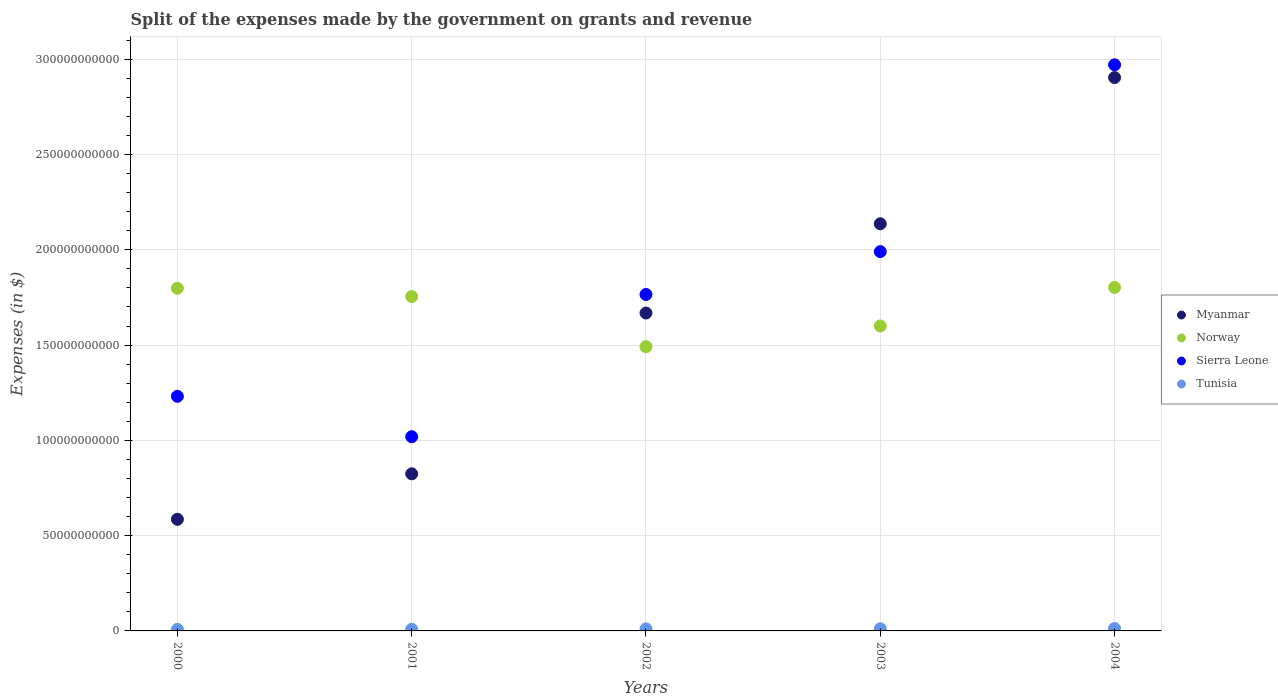How many different coloured dotlines are there?
Provide a short and direct response. 4. What is the expenses made by the government on grants and revenue in Sierra Leone in 2000?
Provide a succinct answer. 1.23e+11. Across all years, what is the maximum expenses made by the government on grants and revenue in Sierra Leone?
Your answer should be compact. 2.97e+11. Across all years, what is the minimum expenses made by the government on grants and revenue in Myanmar?
Keep it short and to the point. 5.86e+1. In which year was the expenses made by the government on grants and revenue in Sierra Leone minimum?
Provide a succinct answer. 2001. What is the total expenses made by the government on grants and revenue in Myanmar in the graph?
Offer a terse response. 8.12e+11. What is the difference between the expenses made by the government on grants and revenue in Sierra Leone in 2000 and that in 2001?
Your answer should be very brief. 2.12e+1. What is the difference between the expenses made by the government on grants and revenue in Norway in 2004 and the expenses made by the government on grants and revenue in Sierra Leone in 2003?
Keep it short and to the point. -1.88e+1. What is the average expenses made by the government on grants and revenue in Sierra Leone per year?
Make the answer very short. 1.80e+11. In the year 2002, what is the difference between the expenses made by the government on grants and revenue in Tunisia and expenses made by the government on grants and revenue in Sierra Leone?
Provide a short and direct response. -1.75e+11. In how many years, is the expenses made by the government on grants and revenue in Norway greater than 190000000000 $?
Keep it short and to the point. 0. What is the ratio of the expenses made by the government on grants and revenue in Sierra Leone in 2001 to that in 2003?
Make the answer very short. 0.51. Is the expenses made by the government on grants and revenue in Tunisia in 2000 less than that in 2004?
Provide a succinct answer. Yes. Is the difference between the expenses made by the government on grants and revenue in Tunisia in 2000 and 2003 greater than the difference between the expenses made by the government on grants and revenue in Sierra Leone in 2000 and 2003?
Provide a short and direct response. Yes. What is the difference between the highest and the second highest expenses made by the government on grants and revenue in Norway?
Provide a succinct answer. 4.25e+08. What is the difference between the highest and the lowest expenses made by the government on grants and revenue in Tunisia?
Give a very brief answer. 4.58e+08. In how many years, is the expenses made by the government on grants and revenue in Norway greater than the average expenses made by the government on grants and revenue in Norway taken over all years?
Give a very brief answer. 3. Is the sum of the expenses made by the government on grants and revenue in Norway in 2001 and 2003 greater than the maximum expenses made by the government on grants and revenue in Tunisia across all years?
Keep it short and to the point. Yes. Is it the case that in every year, the sum of the expenses made by the government on grants and revenue in Tunisia and expenses made by the government on grants and revenue in Sierra Leone  is greater than the sum of expenses made by the government on grants and revenue in Norway and expenses made by the government on grants and revenue in Myanmar?
Offer a terse response. No. Does the expenses made by the government on grants and revenue in Norway monotonically increase over the years?
Provide a succinct answer. No. Is the expenses made by the government on grants and revenue in Myanmar strictly greater than the expenses made by the government on grants and revenue in Norway over the years?
Keep it short and to the point. No. What is the difference between two consecutive major ticks on the Y-axis?
Make the answer very short. 5.00e+1. Does the graph contain any zero values?
Offer a terse response. No. Does the graph contain grids?
Offer a terse response. Yes. Where does the legend appear in the graph?
Ensure brevity in your answer.  Center right. How many legend labels are there?
Your answer should be very brief. 4. How are the legend labels stacked?
Your response must be concise. Vertical. What is the title of the graph?
Ensure brevity in your answer.  Split of the expenses made by the government on grants and revenue. What is the label or title of the Y-axis?
Give a very brief answer. Expenses (in $). What is the Expenses (in $) of Myanmar in 2000?
Your answer should be very brief. 5.86e+1. What is the Expenses (in $) in Norway in 2000?
Offer a very short reply. 1.80e+11. What is the Expenses (in $) in Sierra Leone in 2000?
Your answer should be very brief. 1.23e+11. What is the Expenses (in $) in Tunisia in 2000?
Make the answer very short. 8.20e+08. What is the Expenses (in $) of Myanmar in 2001?
Provide a short and direct response. 8.24e+1. What is the Expenses (in $) in Norway in 2001?
Keep it short and to the point. 1.75e+11. What is the Expenses (in $) in Sierra Leone in 2001?
Your response must be concise. 1.02e+11. What is the Expenses (in $) in Tunisia in 2001?
Provide a short and direct response. 8.76e+08. What is the Expenses (in $) of Myanmar in 2002?
Your answer should be compact. 1.67e+11. What is the Expenses (in $) in Norway in 2002?
Your response must be concise. 1.49e+11. What is the Expenses (in $) in Sierra Leone in 2002?
Offer a terse response. 1.77e+11. What is the Expenses (in $) in Tunisia in 2002?
Make the answer very short. 1.08e+09. What is the Expenses (in $) in Myanmar in 2003?
Offer a very short reply. 2.14e+11. What is the Expenses (in $) of Norway in 2003?
Offer a terse response. 1.60e+11. What is the Expenses (in $) of Sierra Leone in 2003?
Offer a terse response. 1.99e+11. What is the Expenses (in $) in Tunisia in 2003?
Ensure brevity in your answer.  1.14e+09. What is the Expenses (in $) of Myanmar in 2004?
Your answer should be compact. 2.90e+11. What is the Expenses (in $) in Norway in 2004?
Provide a succinct answer. 1.80e+11. What is the Expenses (in $) of Sierra Leone in 2004?
Offer a terse response. 2.97e+11. What is the Expenses (in $) of Tunisia in 2004?
Give a very brief answer. 1.28e+09. Across all years, what is the maximum Expenses (in $) of Myanmar?
Your answer should be compact. 2.90e+11. Across all years, what is the maximum Expenses (in $) of Norway?
Make the answer very short. 1.80e+11. Across all years, what is the maximum Expenses (in $) in Sierra Leone?
Provide a succinct answer. 2.97e+11. Across all years, what is the maximum Expenses (in $) of Tunisia?
Provide a succinct answer. 1.28e+09. Across all years, what is the minimum Expenses (in $) of Myanmar?
Offer a very short reply. 5.86e+1. Across all years, what is the minimum Expenses (in $) of Norway?
Your response must be concise. 1.49e+11. Across all years, what is the minimum Expenses (in $) of Sierra Leone?
Keep it short and to the point. 1.02e+11. Across all years, what is the minimum Expenses (in $) in Tunisia?
Make the answer very short. 8.20e+08. What is the total Expenses (in $) in Myanmar in the graph?
Provide a succinct answer. 8.12e+11. What is the total Expenses (in $) in Norway in the graph?
Give a very brief answer. 8.45e+11. What is the total Expenses (in $) of Sierra Leone in the graph?
Your response must be concise. 8.98e+11. What is the total Expenses (in $) in Tunisia in the graph?
Offer a very short reply. 5.20e+09. What is the difference between the Expenses (in $) of Myanmar in 2000 and that in 2001?
Offer a very short reply. -2.39e+1. What is the difference between the Expenses (in $) in Norway in 2000 and that in 2001?
Your answer should be very brief. 4.36e+09. What is the difference between the Expenses (in $) in Sierra Leone in 2000 and that in 2001?
Your response must be concise. 2.12e+1. What is the difference between the Expenses (in $) in Tunisia in 2000 and that in 2001?
Ensure brevity in your answer.  -5.55e+07. What is the difference between the Expenses (in $) in Myanmar in 2000 and that in 2002?
Your response must be concise. -1.08e+11. What is the difference between the Expenses (in $) of Norway in 2000 and that in 2002?
Offer a very short reply. 3.07e+1. What is the difference between the Expenses (in $) of Sierra Leone in 2000 and that in 2002?
Your answer should be compact. -5.34e+1. What is the difference between the Expenses (in $) in Tunisia in 2000 and that in 2002?
Your response must be concise. -2.64e+08. What is the difference between the Expenses (in $) in Myanmar in 2000 and that in 2003?
Your answer should be very brief. -1.55e+11. What is the difference between the Expenses (in $) in Norway in 2000 and that in 2003?
Keep it short and to the point. 1.98e+1. What is the difference between the Expenses (in $) in Sierra Leone in 2000 and that in 2003?
Give a very brief answer. -7.59e+1. What is the difference between the Expenses (in $) of Tunisia in 2000 and that in 2003?
Provide a short and direct response. -3.21e+08. What is the difference between the Expenses (in $) in Myanmar in 2000 and that in 2004?
Give a very brief answer. -2.32e+11. What is the difference between the Expenses (in $) in Norway in 2000 and that in 2004?
Provide a short and direct response. -4.25e+08. What is the difference between the Expenses (in $) of Sierra Leone in 2000 and that in 2004?
Provide a succinct answer. -1.74e+11. What is the difference between the Expenses (in $) of Tunisia in 2000 and that in 2004?
Provide a short and direct response. -4.58e+08. What is the difference between the Expenses (in $) in Myanmar in 2001 and that in 2002?
Give a very brief answer. -8.44e+1. What is the difference between the Expenses (in $) of Norway in 2001 and that in 2002?
Your answer should be very brief. 2.63e+1. What is the difference between the Expenses (in $) of Sierra Leone in 2001 and that in 2002?
Ensure brevity in your answer.  -7.46e+1. What is the difference between the Expenses (in $) in Tunisia in 2001 and that in 2002?
Provide a short and direct response. -2.09e+08. What is the difference between the Expenses (in $) in Myanmar in 2001 and that in 2003?
Make the answer very short. -1.31e+11. What is the difference between the Expenses (in $) of Norway in 2001 and that in 2003?
Offer a very short reply. 1.54e+1. What is the difference between the Expenses (in $) in Sierra Leone in 2001 and that in 2003?
Keep it short and to the point. -9.71e+1. What is the difference between the Expenses (in $) in Tunisia in 2001 and that in 2003?
Make the answer very short. -2.66e+08. What is the difference between the Expenses (in $) in Myanmar in 2001 and that in 2004?
Your response must be concise. -2.08e+11. What is the difference between the Expenses (in $) in Norway in 2001 and that in 2004?
Keep it short and to the point. -4.79e+09. What is the difference between the Expenses (in $) of Sierra Leone in 2001 and that in 2004?
Your response must be concise. -1.95e+11. What is the difference between the Expenses (in $) in Tunisia in 2001 and that in 2004?
Make the answer very short. -4.02e+08. What is the difference between the Expenses (in $) in Myanmar in 2002 and that in 2003?
Your response must be concise. -4.68e+1. What is the difference between the Expenses (in $) of Norway in 2002 and that in 2003?
Give a very brief answer. -1.09e+1. What is the difference between the Expenses (in $) in Sierra Leone in 2002 and that in 2003?
Keep it short and to the point. -2.25e+1. What is the difference between the Expenses (in $) in Tunisia in 2002 and that in 2003?
Ensure brevity in your answer.  -5.66e+07. What is the difference between the Expenses (in $) in Myanmar in 2002 and that in 2004?
Provide a succinct answer. -1.24e+11. What is the difference between the Expenses (in $) of Norway in 2002 and that in 2004?
Offer a very short reply. -3.11e+1. What is the difference between the Expenses (in $) in Sierra Leone in 2002 and that in 2004?
Provide a succinct answer. -1.21e+11. What is the difference between the Expenses (in $) of Tunisia in 2002 and that in 2004?
Offer a terse response. -1.94e+08. What is the difference between the Expenses (in $) in Myanmar in 2003 and that in 2004?
Provide a short and direct response. -7.67e+1. What is the difference between the Expenses (in $) in Norway in 2003 and that in 2004?
Provide a short and direct response. -2.02e+1. What is the difference between the Expenses (in $) in Sierra Leone in 2003 and that in 2004?
Provide a short and direct response. -9.80e+1. What is the difference between the Expenses (in $) in Tunisia in 2003 and that in 2004?
Give a very brief answer. -1.37e+08. What is the difference between the Expenses (in $) in Myanmar in 2000 and the Expenses (in $) in Norway in 2001?
Your answer should be compact. -1.17e+11. What is the difference between the Expenses (in $) of Myanmar in 2000 and the Expenses (in $) of Sierra Leone in 2001?
Ensure brevity in your answer.  -4.34e+1. What is the difference between the Expenses (in $) in Myanmar in 2000 and the Expenses (in $) in Tunisia in 2001?
Your response must be concise. 5.77e+1. What is the difference between the Expenses (in $) in Norway in 2000 and the Expenses (in $) in Sierra Leone in 2001?
Provide a succinct answer. 7.79e+1. What is the difference between the Expenses (in $) of Norway in 2000 and the Expenses (in $) of Tunisia in 2001?
Keep it short and to the point. 1.79e+11. What is the difference between the Expenses (in $) in Sierra Leone in 2000 and the Expenses (in $) in Tunisia in 2001?
Ensure brevity in your answer.  1.22e+11. What is the difference between the Expenses (in $) of Myanmar in 2000 and the Expenses (in $) of Norway in 2002?
Provide a short and direct response. -9.06e+1. What is the difference between the Expenses (in $) in Myanmar in 2000 and the Expenses (in $) in Sierra Leone in 2002?
Keep it short and to the point. -1.18e+11. What is the difference between the Expenses (in $) in Myanmar in 2000 and the Expenses (in $) in Tunisia in 2002?
Provide a succinct answer. 5.75e+1. What is the difference between the Expenses (in $) in Norway in 2000 and the Expenses (in $) in Sierra Leone in 2002?
Ensure brevity in your answer.  3.26e+09. What is the difference between the Expenses (in $) in Norway in 2000 and the Expenses (in $) in Tunisia in 2002?
Ensure brevity in your answer.  1.79e+11. What is the difference between the Expenses (in $) in Sierra Leone in 2000 and the Expenses (in $) in Tunisia in 2002?
Your answer should be very brief. 1.22e+11. What is the difference between the Expenses (in $) in Myanmar in 2000 and the Expenses (in $) in Norway in 2003?
Keep it short and to the point. -1.01e+11. What is the difference between the Expenses (in $) in Myanmar in 2000 and the Expenses (in $) in Sierra Leone in 2003?
Ensure brevity in your answer.  -1.40e+11. What is the difference between the Expenses (in $) in Myanmar in 2000 and the Expenses (in $) in Tunisia in 2003?
Ensure brevity in your answer.  5.74e+1. What is the difference between the Expenses (in $) in Norway in 2000 and the Expenses (in $) in Sierra Leone in 2003?
Your response must be concise. -1.92e+1. What is the difference between the Expenses (in $) of Norway in 2000 and the Expenses (in $) of Tunisia in 2003?
Make the answer very short. 1.79e+11. What is the difference between the Expenses (in $) of Sierra Leone in 2000 and the Expenses (in $) of Tunisia in 2003?
Your answer should be very brief. 1.22e+11. What is the difference between the Expenses (in $) of Myanmar in 2000 and the Expenses (in $) of Norway in 2004?
Keep it short and to the point. -1.22e+11. What is the difference between the Expenses (in $) of Myanmar in 2000 and the Expenses (in $) of Sierra Leone in 2004?
Make the answer very short. -2.39e+11. What is the difference between the Expenses (in $) of Myanmar in 2000 and the Expenses (in $) of Tunisia in 2004?
Your response must be concise. 5.73e+1. What is the difference between the Expenses (in $) in Norway in 2000 and the Expenses (in $) in Sierra Leone in 2004?
Your response must be concise. -1.17e+11. What is the difference between the Expenses (in $) in Norway in 2000 and the Expenses (in $) in Tunisia in 2004?
Provide a short and direct response. 1.79e+11. What is the difference between the Expenses (in $) of Sierra Leone in 2000 and the Expenses (in $) of Tunisia in 2004?
Provide a short and direct response. 1.22e+11. What is the difference between the Expenses (in $) of Myanmar in 2001 and the Expenses (in $) of Norway in 2002?
Offer a terse response. -6.67e+1. What is the difference between the Expenses (in $) in Myanmar in 2001 and the Expenses (in $) in Sierra Leone in 2002?
Offer a terse response. -9.41e+1. What is the difference between the Expenses (in $) of Myanmar in 2001 and the Expenses (in $) of Tunisia in 2002?
Your answer should be very brief. 8.14e+1. What is the difference between the Expenses (in $) of Norway in 2001 and the Expenses (in $) of Sierra Leone in 2002?
Your response must be concise. -1.10e+09. What is the difference between the Expenses (in $) of Norway in 2001 and the Expenses (in $) of Tunisia in 2002?
Offer a very short reply. 1.74e+11. What is the difference between the Expenses (in $) in Sierra Leone in 2001 and the Expenses (in $) in Tunisia in 2002?
Your response must be concise. 1.01e+11. What is the difference between the Expenses (in $) of Myanmar in 2001 and the Expenses (in $) of Norway in 2003?
Offer a very short reply. -7.76e+1. What is the difference between the Expenses (in $) in Myanmar in 2001 and the Expenses (in $) in Sierra Leone in 2003?
Keep it short and to the point. -1.17e+11. What is the difference between the Expenses (in $) of Myanmar in 2001 and the Expenses (in $) of Tunisia in 2003?
Ensure brevity in your answer.  8.13e+1. What is the difference between the Expenses (in $) of Norway in 2001 and the Expenses (in $) of Sierra Leone in 2003?
Offer a terse response. -2.36e+1. What is the difference between the Expenses (in $) in Norway in 2001 and the Expenses (in $) in Tunisia in 2003?
Offer a terse response. 1.74e+11. What is the difference between the Expenses (in $) of Sierra Leone in 2001 and the Expenses (in $) of Tunisia in 2003?
Give a very brief answer. 1.01e+11. What is the difference between the Expenses (in $) in Myanmar in 2001 and the Expenses (in $) in Norway in 2004?
Your response must be concise. -9.78e+1. What is the difference between the Expenses (in $) of Myanmar in 2001 and the Expenses (in $) of Sierra Leone in 2004?
Provide a succinct answer. -2.15e+11. What is the difference between the Expenses (in $) in Myanmar in 2001 and the Expenses (in $) in Tunisia in 2004?
Make the answer very short. 8.12e+1. What is the difference between the Expenses (in $) of Norway in 2001 and the Expenses (in $) of Sierra Leone in 2004?
Offer a very short reply. -1.22e+11. What is the difference between the Expenses (in $) in Norway in 2001 and the Expenses (in $) in Tunisia in 2004?
Give a very brief answer. 1.74e+11. What is the difference between the Expenses (in $) in Sierra Leone in 2001 and the Expenses (in $) in Tunisia in 2004?
Give a very brief answer. 1.01e+11. What is the difference between the Expenses (in $) in Myanmar in 2002 and the Expenses (in $) in Norway in 2003?
Offer a terse response. 6.78e+09. What is the difference between the Expenses (in $) of Myanmar in 2002 and the Expenses (in $) of Sierra Leone in 2003?
Offer a very short reply. -3.22e+1. What is the difference between the Expenses (in $) of Myanmar in 2002 and the Expenses (in $) of Tunisia in 2003?
Ensure brevity in your answer.  1.66e+11. What is the difference between the Expenses (in $) of Norway in 2002 and the Expenses (in $) of Sierra Leone in 2003?
Your response must be concise. -4.99e+1. What is the difference between the Expenses (in $) of Norway in 2002 and the Expenses (in $) of Tunisia in 2003?
Keep it short and to the point. 1.48e+11. What is the difference between the Expenses (in $) of Sierra Leone in 2002 and the Expenses (in $) of Tunisia in 2003?
Make the answer very short. 1.75e+11. What is the difference between the Expenses (in $) of Myanmar in 2002 and the Expenses (in $) of Norway in 2004?
Provide a short and direct response. -1.34e+1. What is the difference between the Expenses (in $) in Myanmar in 2002 and the Expenses (in $) in Sierra Leone in 2004?
Your answer should be very brief. -1.30e+11. What is the difference between the Expenses (in $) in Myanmar in 2002 and the Expenses (in $) in Tunisia in 2004?
Keep it short and to the point. 1.66e+11. What is the difference between the Expenses (in $) in Norway in 2002 and the Expenses (in $) in Sierra Leone in 2004?
Your response must be concise. -1.48e+11. What is the difference between the Expenses (in $) in Norway in 2002 and the Expenses (in $) in Tunisia in 2004?
Keep it short and to the point. 1.48e+11. What is the difference between the Expenses (in $) in Sierra Leone in 2002 and the Expenses (in $) in Tunisia in 2004?
Ensure brevity in your answer.  1.75e+11. What is the difference between the Expenses (in $) in Myanmar in 2003 and the Expenses (in $) in Norway in 2004?
Ensure brevity in your answer.  3.34e+1. What is the difference between the Expenses (in $) in Myanmar in 2003 and the Expenses (in $) in Sierra Leone in 2004?
Provide a succinct answer. -8.34e+1. What is the difference between the Expenses (in $) in Myanmar in 2003 and the Expenses (in $) in Tunisia in 2004?
Your answer should be very brief. 2.12e+11. What is the difference between the Expenses (in $) of Norway in 2003 and the Expenses (in $) of Sierra Leone in 2004?
Keep it short and to the point. -1.37e+11. What is the difference between the Expenses (in $) in Norway in 2003 and the Expenses (in $) in Tunisia in 2004?
Provide a succinct answer. 1.59e+11. What is the difference between the Expenses (in $) in Sierra Leone in 2003 and the Expenses (in $) in Tunisia in 2004?
Your answer should be compact. 1.98e+11. What is the average Expenses (in $) of Myanmar per year?
Make the answer very short. 1.62e+11. What is the average Expenses (in $) in Norway per year?
Provide a succinct answer. 1.69e+11. What is the average Expenses (in $) in Sierra Leone per year?
Your answer should be compact. 1.80e+11. What is the average Expenses (in $) in Tunisia per year?
Your answer should be compact. 1.04e+09. In the year 2000, what is the difference between the Expenses (in $) of Myanmar and Expenses (in $) of Norway?
Make the answer very short. -1.21e+11. In the year 2000, what is the difference between the Expenses (in $) in Myanmar and Expenses (in $) in Sierra Leone?
Keep it short and to the point. -6.45e+1. In the year 2000, what is the difference between the Expenses (in $) of Myanmar and Expenses (in $) of Tunisia?
Give a very brief answer. 5.77e+1. In the year 2000, what is the difference between the Expenses (in $) in Norway and Expenses (in $) in Sierra Leone?
Your answer should be compact. 5.67e+1. In the year 2000, what is the difference between the Expenses (in $) in Norway and Expenses (in $) in Tunisia?
Your response must be concise. 1.79e+11. In the year 2000, what is the difference between the Expenses (in $) of Sierra Leone and Expenses (in $) of Tunisia?
Make the answer very short. 1.22e+11. In the year 2001, what is the difference between the Expenses (in $) in Myanmar and Expenses (in $) in Norway?
Provide a succinct answer. -9.30e+1. In the year 2001, what is the difference between the Expenses (in $) in Myanmar and Expenses (in $) in Sierra Leone?
Your answer should be compact. -1.95e+1. In the year 2001, what is the difference between the Expenses (in $) in Myanmar and Expenses (in $) in Tunisia?
Your answer should be compact. 8.16e+1. In the year 2001, what is the difference between the Expenses (in $) of Norway and Expenses (in $) of Sierra Leone?
Ensure brevity in your answer.  7.35e+1. In the year 2001, what is the difference between the Expenses (in $) of Norway and Expenses (in $) of Tunisia?
Make the answer very short. 1.75e+11. In the year 2001, what is the difference between the Expenses (in $) in Sierra Leone and Expenses (in $) in Tunisia?
Your answer should be compact. 1.01e+11. In the year 2002, what is the difference between the Expenses (in $) of Myanmar and Expenses (in $) of Norway?
Ensure brevity in your answer.  1.77e+1. In the year 2002, what is the difference between the Expenses (in $) of Myanmar and Expenses (in $) of Sierra Leone?
Your response must be concise. -9.74e+09. In the year 2002, what is the difference between the Expenses (in $) of Myanmar and Expenses (in $) of Tunisia?
Provide a succinct answer. 1.66e+11. In the year 2002, what is the difference between the Expenses (in $) of Norway and Expenses (in $) of Sierra Leone?
Give a very brief answer. -2.74e+1. In the year 2002, what is the difference between the Expenses (in $) in Norway and Expenses (in $) in Tunisia?
Offer a terse response. 1.48e+11. In the year 2002, what is the difference between the Expenses (in $) of Sierra Leone and Expenses (in $) of Tunisia?
Your answer should be compact. 1.75e+11. In the year 2003, what is the difference between the Expenses (in $) of Myanmar and Expenses (in $) of Norway?
Your answer should be very brief. 5.36e+1. In the year 2003, what is the difference between the Expenses (in $) of Myanmar and Expenses (in $) of Sierra Leone?
Provide a short and direct response. 1.46e+1. In the year 2003, what is the difference between the Expenses (in $) in Myanmar and Expenses (in $) in Tunisia?
Keep it short and to the point. 2.13e+11. In the year 2003, what is the difference between the Expenses (in $) in Norway and Expenses (in $) in Sierra Leone?
Your answer should be very brief. -3.90e+1. In the year 2003, what is the difference between the Expenses (in $) of Norway and Expenses (in $) of Tunisia?
Your answer should be compact. 1.59e+11. In the year 2003, what is the difference between the Expenses (in $) of Sierra Leone and Expenses (in $) of Tunisia?
Offer a very short reply. 1.98e+11. In the year 2004, what is the difference between the Expenses (in $) of Myanmar and Expenses (in $) of Norway?
Give a very brief answer. 1.10e+11. In the year 2004, what is the difference between the Expenses (in $) of Myanmar and Expenses (in $) of Sierra Leone?
Keep it short and to the point. -6.71e+09. In the year 2004, what is the difference between the Expenses (in $) of Myanmar and Expenses (in $) of Tunisia?
Give a very brief answer. 2.89e+11. In the year 2004, what is the difference between the Expenses (in $) of Norway and Expenses (in $) of Sierra Leone?
Your answer should be very brief. -1.17e+11. In the year 2004, what is the difference between the Expenses (in $) in Norway and Expenses (in $) in Tunisia?
Keep it short and to the point. 1.79e+11. In the year 2004, what is the difference between the Expenses (in $) of Sierra Leone and Expenses (in $) of Tunisia?
Ensure brevity in your answer.  2.96e+11. What is the ratio of the Expenses (in $) of Myanmar in 2000 to that in 2001?
Your answer should be very brief. 0.71. What is the ratio of the Expenses (in $) of Norway in 2000 to that in 2001?
Your answer should be compact. 1.02. What is the ratio of the Expenses (in $) in Sierra Leone in 2000 to that in 2001?
Offer a very short reply. 1.21. What is the ratio of the Expenses (in $) in Tunisia in 2000 to that in 2001?
Make the answer very short. 0.94. What is the ratio of the Expenses (in $) of Myanmar in 2000 to that in 2002?
Your response must be concise. 0.35. What is the ratio of the Expenses (in $) of Norway in 2000 to that in 2002?
Keep it short and to the point. 1.21. What is the ratio of the Expenses (in $) in Sierra Leone in 2000 to that in 2002?
Your answer should be compact. 0.7. What is the ratio of the Expenses (in $) in Tunisia in 2000 to that in 2002?
Offer a very short reply. 0.76. What is the ratio of the Expenses (in $) of Myanmar in 2000 to that in 2003?
Make the answer very short. 0.27. What is the ratio of the Expenses (in $) in Norway in 2000 to that in 2003?
Provide a short and direct response. 1.12. What is the ratio of the Expenses (in $) in Sierra Leone in 2000 to that in 2003?
Your answer should be very brief. 0.62. What is the ratio of the Expenses (in $) in Tunisia in 2000 to that in 2003?
Keep it short and to the point. 0.72. What is the ratio of the Expenses (in $) in Myanmar in 2000 to that in 2004?
Provide a short and direct response. 0.2. What is the ratio of the Expenses (in $) in Norway in 2000 to that in 2004?
Offer a very short reply. 1. What is the ratio of the Expenses (in $) in Sierra Leone in 2000 to that in 2004?
Offer a terse response. 0.41. What is the ratio of the Expenses (in $) in Tunisia in 2000 to that in 2004?
Keep it short and to the point. 0.64. What is the ratio of the Expenses (in $) in Myanmar in 2001 to that in 2002?
Your answer should be very brief. 0.49. What is the ratio of the Expenses (in $) in Norway in 2001 to that in 2002?
Your answer should be compact. 1.18. What is the ratio of the Expenses (in $) in Sierra Leone in 2001 to that in 2002?
Provide a short and direct response. 0.58. What is the ratio of the Expenses (in $) in Tunisia in 2001 to that in 2002?
Provide a succinct answer. 0.81. What is the ratio of the Expenses (in $) in Myanmar in 2001 to that in 2003?
Ensure brevity in your answer.  0.39. What is the ratio of the Expenses (in $) of Norway in 2001 to that in 2003?
Make the answer very short. 1.1. What is the ratio of the Expenses (in $) in Sierra Leone in 2001 to that in 2003?
Your answer should be compact. 0.51. What is the ratio of the Expenses (in $) of Tunisia in 2001 to that in 2003?
Give a very brief answer. 0.77. What is the ratio of the Expenses (in $) in Myanmar in 2001 to that in 2004?
Your answer should be very brief. 0.28. What is the ratio of the Expenses (in $) in Norway in 2001 to that in 2004?
Provide a short and direct response. 0.97. What is the ratio of the Expenses (in $) in Sierra Leone in 2001 to that in 2004?
Your response must be concise. 0.34. What is the ratio of the Expenses (in $) of Tunisia in 2001 to that in 2004?
Keep it short and to the point. 0.69. What is the ratio of the Expenses (in $) of Myanmar in 2002 to that in 2003?
Offer a very short reply. 0.78. What is the ratio of the Expenses (in $) in Norway in 2002 to that in 2003?
Give a very brief answer. 0.93. What is the ratio of the Expenses (in $) of Sierra Leone in 2002 to that in 2003?
Make the answer very short. 0.89. What is the ratio of the Expenses (in $) in Tunisia in 2002 to that in 2003?
Offer a very short reply. 0.95. What is the ratio of the Expenses (in $) in Myanmar in 2002 to that in 2004?
Offer a terse response. 0.57. What is the ratio of the Expenses (in $) in Norway in 2002 to that in 2004?
Ensure brevity in your answer.  0.83. What is the ratio of the Expenses (in $) in Sierra Leone in 2002 to that in 2004?
Provide a succinct answer. 0.59. What is the ratio of the Expenses (in $) in Tunisia in 2002 to that in 2004?
Make the answer very short. 0.85. What is the ratio of the Expenses (in $) in Myanmar in 2003 to that in 2004?
Your response must be concise. 0.74. What is the ratio of the Expenses (in $) of Norway in 2003 to that in 2004?
Provide a succinct answer. 0.89. What is the ratio of the Expenses (in $) in Sierra Leone in 2003 to that in 2004?
Provide a short and direct response. 0.67. What is the ratio of the Expenses (in $) of Tunisia in 2003 to that in 2004?
Your answer should be compact. 0.89. What is the difference between the highest and the second highest Expenses (in $) in Myanmar?
Give a very brief answer. 7.67e+1. What is the difference between the highest and the second highest Expenses (in $) of Norway?
Offer a terse response. 4.25e+08. What is the difference between the highest and the second highest Expenses (in $) in Sierra Leone?
Make the answer very short. 9.80e+1. What is the difference between the highest and the second highest Expenses (in $) in Tunisia?
Provide a short and direct response. 1.37e+08. What is the difference between the highest and the lowest Expenses (in $) in Myanmar?
Your response must be concise. 2.32e+11. What is the difference between the highest and the lowest Expenses (in $) in Norway?
Make the answer very short. 3.11e+1. What is the difference between the highest and the lowest Expenses (in $) of Sierra Leone?
Make the answer very short. 1.95e+11. What is the difference between the highest and the lowest Expenses (in $) of Tunisia?
Your response must be concise. 4.58e+08. 